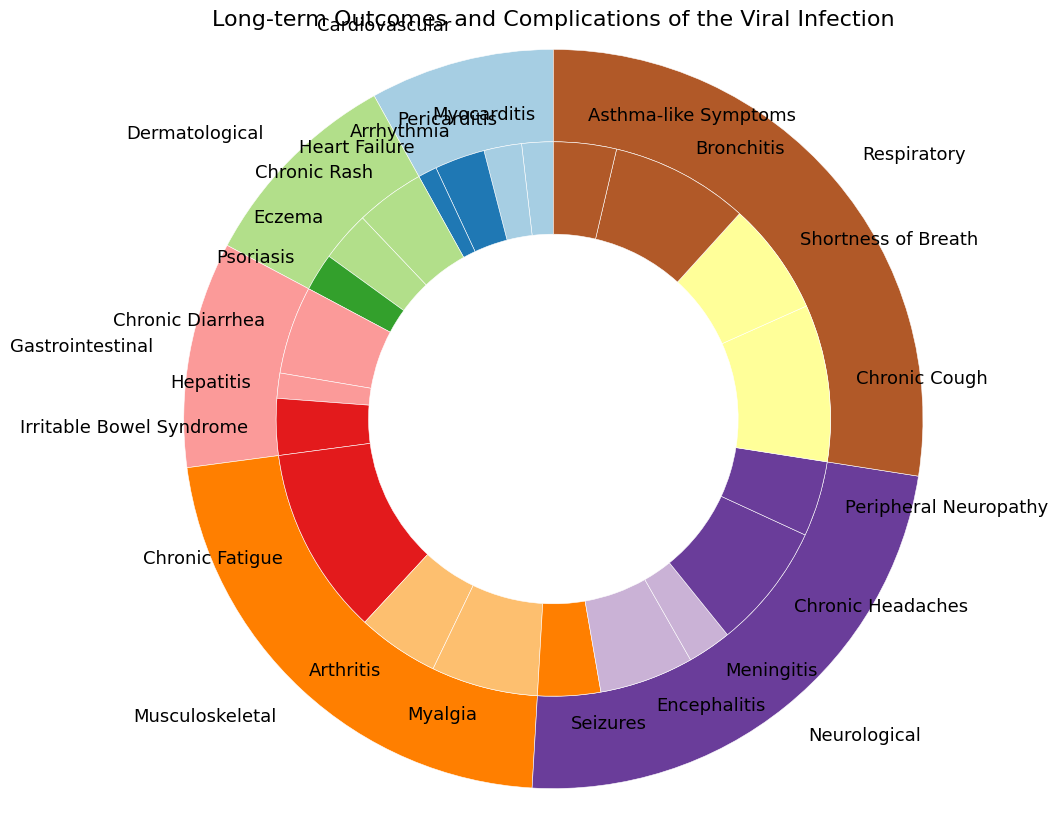How many more cases of Chronic Cough are there compared to Seizures? First, identify the counts for Chronic Cough (25) and Seizures (10) from the figure. Then subtract the count of Seizures from the count of Chronic Cough: 25 - 10 = 15
Answer: 15 Which type of complication has the highest total number of cases? Sum the counts of complications within each type: Neurological (64), Respiratory (75), Cardiovascular (22), Gastrointestinal (27), Musculoskeletal (60), Dermatological (25). The Respiratory type has the highest total.
Answer: Respiratory What is the ratio of cases with Chronic Fatigue to cases with Peripheral Neuropathy? Identify the counts for Chronic Fatigue (30) and Peripheral Neuropathy (12) from the figure. Then divide the count of Chronic Fatigue by the count of Peripheral Neuropathy: 30 / 12 = 2.5
Answer: 2.5 What percentage of total cases are accounted for by Chronic Diarrhea? First, sum all counts to get the total number of cases: 64 (Neurological) + 75 (Respiratory) + 22 (Cardiovascular) + 27 (Gastrointestinal) + 60 (Musculoskeletal) + 25 (Dermatological) = 273. Next, divide the count for Chronic Diarrhea by the total number of cases and multiply by 100: (14 / 273) * 100 ≈ 5.13%
Answer: 5.13% Between Arrhythmia and Heart Failure, which complication has more cases and by how much? Identify the counts for Arrhythmia (8) and Heart Failure (3) from the figure. Then subtract the count of Heart Failure from the count of Arrhythmia: 8 - 3 = 5
Answer: Arrhythmia, by 5 Which type of complication has the fewest cases, and what is the total count for that type? Sum the counts for each type and identify the type with the fewest cases: Cardiovascular (22) has the fewest cases.
Answer: Cardiovascular, 22 How many total cases are there within the Musculoskeletal type of complications? Sum the counts for Chronic Fatigue (30), Arthritis (13), and Myalgia (17) within the Musculoskeletal type: 30 + 13 + 17 = 60
Answer: 60 Compare the number of cases of Chronic Rash and Encephalitis. Which has fewer cases? Identify the counts for Chronic Rash (11) and Encephalitis (15) from the figure. Chronic Rash has fewer cases.
Answer: Chronic Rash Calculate the average number of cases per complication for the Dermatological type. Sum the counts for all Dermatological complications (Chronic Rash: 11, Eczema: 8, Psoriasis: 6) and divide by the number of Dermatological complications: (11 + 8 + 6) / 3 = 25 / 3 ≈ 8.33
Answer: 8.33 